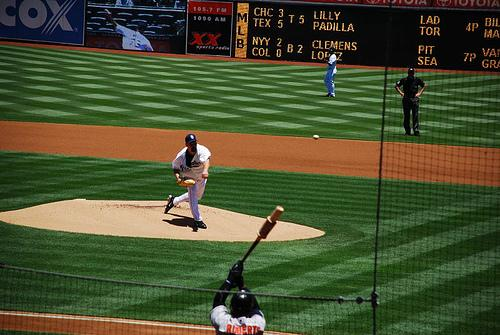Who conducts baseball league? mlb 